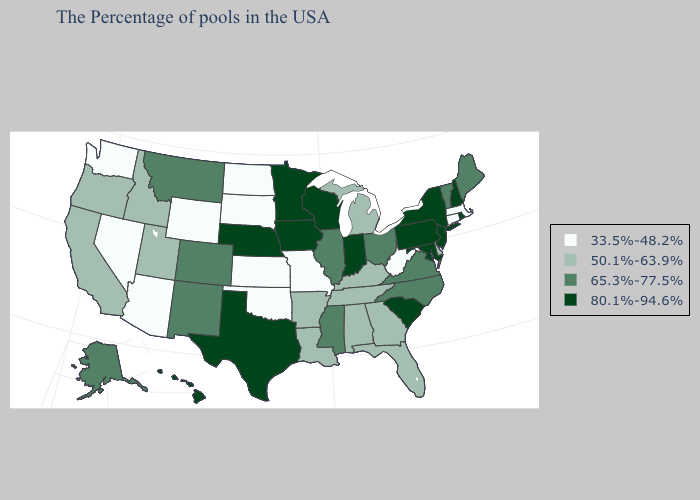Which states have the lowest value in the USA?
Answer briefly. Massachusetts, Connecticut, West Virginia, Missouri, Kansas, Oklahoma, South Dakota, North Dakota, Wyoming, Arizona, Nevada, Washington. Is the legend a continuous bar?
Answer briefly. No. Does Utah have the same value as South Carolina?
Short answer required. No. Does Maine have the lowest value in the Northeast?
Answer briefly. No. Name the states that have a value in the range 65.3%-77.5%?
Answer briefly. Maine, Vermont, Virginia, North Carolina, Ohio, Illinois, Mississippi, Colorado, New Mexico, Montana, Alaska. Name the states that have a value in the range 50.1%-63.9%?
Keep it brief. Delaware, Florida, Georgia, Michigan, Kentucky, Alabama, Tennessee, Louisiana, Arkansas, Utah, Idaho, California, Oregon. Does Hawaii have the highest value in the West?
Answer briefly. Yes. Does Wisconsin have the same value as Massachusetts?
Be succinct. No. Does the map have missing data?
Keep it brief. No. Does the map have missing data?
Be succinct. No. Name the states that have a value in the range 65.3%-77.5%?
Write a very short answer. Maine, Vermont, Virginia, North Carolina, Ohio, Illinois, Mississippi, Colorado, New Mexico, Montana, Alaska. Name the states that have a value in the range 65.3%-77.5%?
Write a very short answer. Maine, Vermont, Virginia, North Carolina, Ohio, Illinois, Mississippi, Colorado, New Mexico, Montana, Alaska. Among the states that border New Hampshire , does Maine have the highest value?
Answer briefly. Yes. Name the states that have a value in the range 50.1%-63.9%?
Short answer required. Delaware, Florida, Georgia, Michigan, Kentucky, Alabama, Tennessee, Louisiana, Arkansas, Utah, Idaho, California, Oregon. 